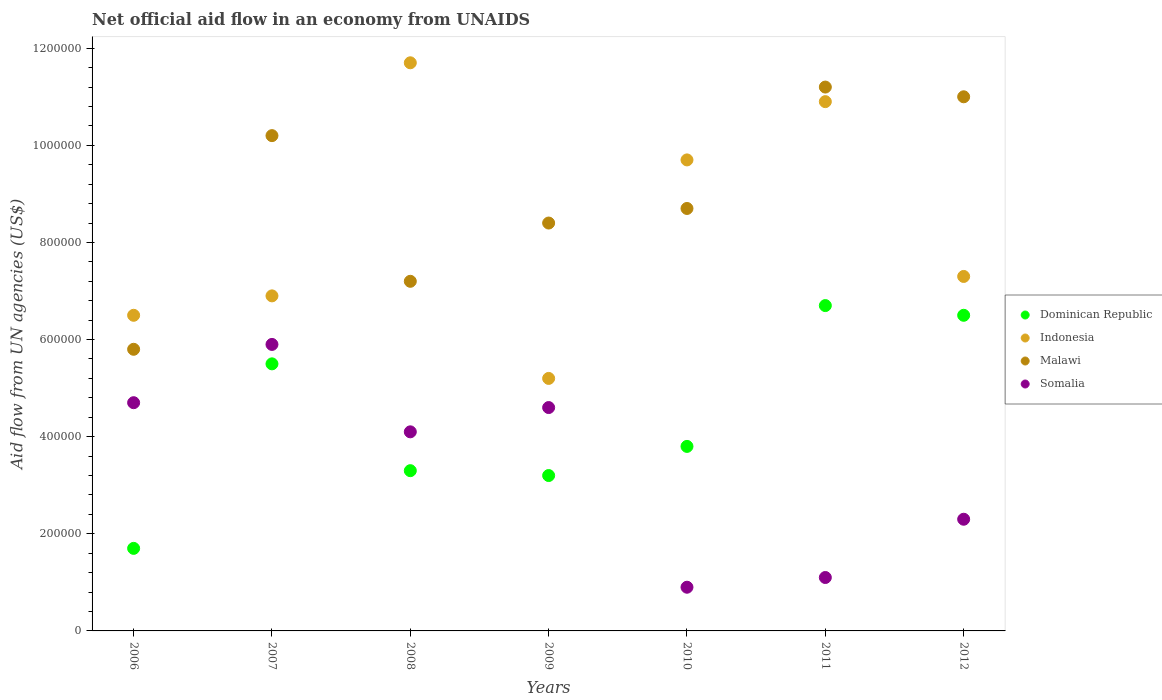How many different coloured dotlines are there?
Your response must be concise. 4. What is the net official aid flow in Indonesia in 2006?
Give a very brief answer. 6.50e+05. Across all years, what is the maximum net official aid flow in Malawi?
Offer a very short reply. 1.12e+06. Across all years, what is the minimum net official aid flow in Somalia?
Give a very brief answer. 9.00e+04. In which year was the net official aid flow in Somalia maximum?
Ensure brevity in your answer.  2007. In which year was the net official aid flow in Somalia minimum?
Offer a terse response. 2010. What is the total net official aid flow in Dominican Republic in the graph?
Provide a succinct answer. 3.07e+06. What is the difference between the net official aid flow in Somalia in 2009 and that in 2010?
Give a very brief answer. 3.70e+05. What is the difference between the net official aid flow in Malawi in 2007 and the net official aid flow in Dominican Republic in 2010?
Offer a terse response. 6.40e+05. What is the average net official aid flow in Dominican Republic per year?
Your response must be concise. 4.39e+05. In the year 2012, what is the difference between the net official aid flow in Somalia and net official aid flow in Dominican Republic?
Offer a terse response. -4.20e+05. What is the ratio of the net official aid flow in Dominican Republic in 2007 to that in 2011?
Your answer should be compact. 0.82. Is the difference between the net official aid flow in Somalia in 2007 and 2011 greater than the difference between the net official aid flow in Dominican Republic in 2007 and 2011?
Offer a very short reply. Yes. What is the difference between the highest and the second highest net official aid flow in Indonesia?
Offer a terse response. 8.00e+04. What is the difference between the highest and the lowest net official aid flow in Somalia?
Make the answer very short. 5.00e+05. Is the sum of the net official aid flow in Malawi in 2006 and 2009 greater than the maximum net official aid flow in Indonesia across all years?
Your response must be concise. Yes. Is it the case that in every year, the sum of the net official aid flow in Malawi and net official aid flow in Dominican Republic  is greater than the sum of net official aid flow in Indonesia and net official aid flow in Somalia?
Keep it short and to the point. No. Is the net official aid flow in Somalia strictly less than the net official aid flow in Dominican Republic over the years?
Make the answer very short. No. What is the difference between two consecutive major ticks on the Y-axis?
Provide a short and direct response. 2.00e+05. Does the graph contain any zero values?
Offer a very short reply. No. Does the graph contain grids?
Your answer should be very brief. No. Where does the legend appear in the graph?
Your answer should be compact. Center right. How are the legend labels stacked?
Offer a terse response. Vertical. What is the title of the graph?
Provide a short and direct response. Net official aid flow in an economy from UNAIDS. Does "Middle East & North Africa (developing only)" appear as one of the legend labels in the graph?
Offer a very short reply. No. What is the label or title of the Y-axis?
Your answer should be very brief. Aid flow from UN agencies (US$). What is the Aid flow from UN agencies (US$) in Indonesia in 2006?
Offer a terse response. 6.50e+05. What is the Aid flow from UN agencies (US$) in Malawi in 2006?
Your answer should be compact. 5.80e+05. What is the Aid flow from UN agencies (US$) in Somalia in 2006?
Provide a succinct answer. 4.70e+05. What is the Aid flow from UN agencies (US$) of Dominican Republic in 2007?
Offer a terse response. 5.50e+05. What is the Aid flow from UN agencies (US$) in Indonesia in 2007?
Your answer should be very brief. 6.90e+05. What is the Aid flow from UN agencies (US$) in Malawi in 2007?
Give a very brief answer. 1.02e+06. What is the Aid flow from UN agencies (US$) of Somalia in 2007?
Your response must be concise. 5.90e+05. What is the Aid flow from UN agencies (US$) in Indonesia in 2008?
Provide a succinct answer. 1.17e+06. What is the Aid flow from UN agencies (US$) in Malawi in 2008?
Provide a succinct answer. 7.20e+05. What is the Aid flow from UN agencies (US$) in Indonesia in 2009?
Offer a very short reply. 5.20e+05. What is the Aid flow from UN agencies (US$) in Malawi in 2009?
Your answer should be very brief. 8.40e+05. What is the Aid flow from UN agencies (US$) of Dominican Republic in 2010?
Ensure brevity in your answer.  3.80e+05. What is the Aid flow from UN agencies (US$) in Indonesia in 2010?
Your response must be concise. 9.70e+05. What is the Aid flow from UN agencies (US$) in Malawi in 2010?
Provide a short and direct response. 8.70e+05. What is the Aid flow from UN agencies (US$) of Dominican Republic in 2011?
Give a very brief answer. 6.70e+05. What is the Aid flow from UN agencies (US$) of Indonesia in 2011?
Offer a terse response. 1.09e+06. What is the Aid flow from UN agencies (US$) of Malawi in 2011?
Your answer should be compact. 1.12e+06. What is the Aid flow from UN agencies (US$) of Dominican Republic in 2012?
Provide a succinct answer. 6.50e+05. What is the Aid flow from UN agencies (US$) in Indonesia in 2012?
Offer a terse response. 7.30e+05. What is the Aid flow from UN agencies (US$) of Malawi in 2012?
Your answer should be compact. 1.10e+06. What is the Aid flow from UN agencies (US$) of Somalia in 2012?
Offer a very short reply. 2.30e+05. Across all years, what is the maximum Aid flow from UN agencies (US$) of Dominican Republic?
Give a very brief answer. 6.70e+05. Across all years, what is the maximum Aid flow from UN agencies (US$) of Indonesia?
Your answer should be very brief. 1.17e+06. Across all years, what is the maximum Aid flow from UN agencies (US$) in Malawi?
Offer a terse response. 1.12e+06. Across all years, what is the maximum Aid flow from UN agencies (US$) of Somalia?
Ensure brevity in your answer.  5.90e+05. Across all years, what is the minimum Aid flow from UN agencies (US$) of Dominican Republic?
Provide a short and direct response. 1.70e+05. Across all years, what is the minimum Aid flow from UN agencies (US$) in Indonesia?
Provide a succinct answer. 5.20e+05. Across all years, what is the minimum Aid flow from UN agencies (US$) in Malawi?
Offer a very short reply. 5.80e+05. Across all years, what is the minimum Aid flow from UN agencies (US$) in Somalia?
Your response must be concise. 9.00e+04. What is the total Aid flow from UN agencies (US$) of Dominican Republic in the graph?
Offer a terse response. 3.07e+06. What is the total Aid flow from UN agencies (US$) in Indonesia in the graph?
Make the answer very short. 5.82e+06. What is the total Aid flow from UN agencies (US$) of Malawi in the graph?
Offer a very short reply. 6.25e+06. What is the total Aid flow from UN agencies (US$) of Somalia in the graph?
Provide a succinct answer. 2.36e+06. What is the difference between the Aid flow from UN agencies (US$) of Dominican Republic in 2006 and that in 2007?
Provide a short and direct response. -3.80e+05. What is the difference between the Aid flow from UN agencies (US$) in Malawi in 2006 and that in 2007?
Your answer should be very brief. -4.40e+05. What is the difference between the Aid flow from UN agencies (US$) in Dominican Republic in 2006 and that in 2008?
Offer a terse response. -1.60e+05. What is the difference between the Aid flow from UN agencies (US$) in Indonesia in 2006 and that in 2008?
Offer a very short reply. -5.20e+05. What is the difference between the Aid flow from UN agencies (US$) in Malawi in 2006 and that in 2008?
Ensure brevity in your answer.  -1.40e+05. What is the difference between the Aid flow from UN agencies (US$) in Somalia in 2006 and that in 2008?
Make the answer very short. 6.00e+04. What is the difference between the Aid flow from UN agencies (US$) in Malawi in 2006 and that in 2009?
Your answer should be compact. -2.60e+05. What is the difference between the Aid flow from UN agencies (US$) in Somalia in 2006 and that in 2009?
Make the answer very short. 10000. What is the difference between the Aid flow from UN agencies (US$) in Dominican Republic in 2006 and that in 2010?
Ensure brevity in your answer.  -2.10e+05. What is the difference between the Aid flow from UN agencies (US$) of Indonesia in 2006 and that in 2010?
Make the answer very short. -3.20e+05. What is the difference between the Aid flow from UN agencies (US$) of Somalia in 2006 and that in 2010?
Keep it short and to the point. 3.80e+05. What is the difference between the Aid flow from UN agencies (US$) of Dominican Republic in 2006 and that in 2011?
Offer a terse response. -5.00e+05. What is the difference between the Aid flow from UN agencies (US$) of Indonesia in 2006 and that in 2011?
Give a very brief answer. -4.40e+05. What is the difference between the Aid flow from UN agencies (US$) of Malawi in 2006 and that in 2011?
Offer a terse response. -5.40e+05. What is the difference between the Aid flow from UN agencies (US$) in Somalia in 2006 and that in 2011?
Offer a terse response. 3.60e+05. What is the difference between the Aid flow from UN agencies (US$) of Dominican Republic in 2006 and that in 2012?
Your response must be concise. -4.80e+05. What is the difference between the Aid flow from UN agencies (US$) in Indonesia in 2006 and that in 2012?
Your answer should be compact. -8.00e+04. What is the difference between the Aid flow from UN agencies (US$) in Malawi in 2006 and that in 2012?
Keep it short and to the point. -5.20e+05. What is the difference between the Aid flow from UN agencies (US$) of Somalia in 2006 and that in 2012?
Give a very brief answer. 2.40e+05. What is the difference between the Aid flow from UN agencies (US$) of Dominican Republic in 2007 and that in 2008?
Offer a very short reply. 2.20e+05. What is the difference between the Aid flow from UN agencies (US$) of Indonesia in 2007 and that in 2008?
Ensure brevity in your answer.  -4.80e+05. What is the difference between the Aid flow from UN agencies (US$) in Malawi in 2007 and that in 2008?
Provide a short and direct response. 3.00e+05. What is the difference between the Aid flow from UN agencies (US$) in Dominican Republic in 2007 and that in 2009?
Offer a terse response. 2.30e+05. What is the difference between the Aid flow from UN agencies (US$) of Indonesia in 2007 and that in 2009?
Offer a terse response. 1.70e+05. What is the difference between the Aid flow from UN agencies (US$) of Somalia in 2007 and that in 2009?
Offer a very short reply. 1.30e+05. What is the difference between the Aid flow from UN agencies (US$) in Indonesia in 2007 and that in 2010?
Provide a short and direct response. -2.80e+05. What is the difference between the Aid flow from UN agencies (US$) of Somalia in 2007 and that in 2010?
Ensure brevity in your answer.  5.00e+05. What is the difference between the Aid flow from UN agencies (US$) of Indonesia in 2007 and that in 2011?
Provide a succinct answer. -4.00e+05. What is the difference between the Aid flow from UN agencies (US$) of Malawi in 2007 and that in 2011?
Make the answer very short. -1.00e+05. What is the difference between the Aid flow from UN agencies (US$) in Somalia in 2007 and that in 2011?
Offer a very short reply. 4.80e+05. What is the difference between the Aid flow from UN agencies (US$) in Indonesia in 2007 and that in 2012?
Your response must be concise. -4.00e+04. What is the difference between the Aid flow from UN agencies (US$) in Indonesia in 2008 and that in 2009?
Provide a short and direct response. 6.50e+05. What is the difference between the Aid flow from UN agencies (US$) in Malawi in 2008 and that in 2010?
Offer a terse response. -1.50e+05. What is the difference between the Aid flow from UN agencies (US$) in Somalia in 2008 and that in 2010?
Keep it short and to the point. 3.20e+05. What is the difference between the Aid flow from UN agencies (US$) in Dominican Republic in 2008 and that in 2011?
Make the answer very short. -3.40e+05. What is the difference between the Aid flow from UN agencies (US$) in Indonesia in 2008 and that in 2011?
Your answer should be compact. 8.00e+04. What is the difference between the Aid flow from UN agencies (US$) in Malawi in 2008 and that in 2011?
Keep it short and to the point. -4.00e+05. What is the difference between the Aid flow from UN agencies (US$) of Dominican Republic in 2008 and that in 2012?
Offer a very short reply. -3.20e+05. What is the difference between the Aid flow from UN agencies (US$) of Indonesia in 2008 and that in 2012?
Offer a very short reply. 4.40e+05. What is the difference between the Aid flow from UN agencies (US$) in Malawi in 2008 and that in 2012?
Your answer should be compact. -3.80e+05. What is the difference between the Aid flow from UN agencies (US$) of Somalia in 2008 and that in 2012?
Provide a short and direct response. 1.80e+05. What is the difference between the Aid flow from UN agencies (US$) in Indonesia in 2009 and that in 2010?
Keep it short and to the point. -4.50e+05. What is the difference between the Aid flow from UN agencies (US$) of Malawi in 2009 and that in 2010?
Your answer should be compact. -3.00e+04. What is the difference between the Aid flow from UN agencies (US$) of Dominican Republic in 2009 and that in 2011?
Your answer should be very brief. -3.50e+05. What is the difference between the Aid flow from UN agencies (US$) of Indonesia in 2009 and that in 2011?
Offer a very short reply. -5.70e+05. What is the difference between the Aid flow from UN agencies (US$) in Malawi in 2009 and that in 2011?
Offer a terse response. -2.80e+05. What is the difference between the Aid flow from UN agencies (US$) in Dominican Republic in 2009 and that in 2012?
Keep it short and to the point. -3.30e+05. What is the difference between the Aid flow from UN agencies (US$) in Malawi in 2009 and that in 2012?
Your answer should be compact. -2.60e+05. What is the difference between the Aid flow from UN agencies (US$) in Malawi in 2010 and that in 2012?
Your response must be concise. -2.30e+05. What is the difference between the Aid flow from UN agencies (US$) in Somalia in 2010 and that in 2012?
Your response must be concise. -1.40e+05. What is the difference between the Aid flow from UN agencies (US$) in Indonesia in 2011 and that in 2012?
Ensure brevity in your answer.  3.60e+05. What is the difference between the Aid flow from UN agencies (US$) of Dominican Republic in 2006 and the Aid flow from UN agencies (US$) of Indonesia in 2007?
Make the answer very short. -5.20e+05. What is the difference between the Aid flow from UN agencies (US$) in Dominican Republic in 2006 and the Aid flow from UN agencies (US$) in Malawi in 2007?
Your answer should be very brief. -8.50e+05. What is the difference between the Aid flow from UN agencies (US$) in Dominican Republic in 2006 and the Aid flow from UN agencies (US$) in Somalia in 2007?
Offer a very short reply. -4.20e+05. What is the difference between the Aid flow from UN agencies (US$) in Indonesia in 2006 and the Aid flow from UN agencies (US$) in Malawi in 2007?
Ensure brevity in your answer.  -3.70e+05. What is the difference between the Aid flow from UN agencies (US$) in Indonesia in 2006 and the Aid flow from UN agencies (US$) in Somalia in 2007?
Make the answer very short. 6.00e+04. What is the difference between the Aid flow from UN agencies (US$) in Dominican Republic in 2006 and the Aid flow from UN agencies (US$) in Indonesia in 2008?
Provide a short and direct response. -1.00e+06. What is the difference between the Aid flow from UN agencies (US$) in Dominican Republic in 2006 and the Aid flow from UN agencies (US$) in Malawi in 2008?
Make the answer very short. -5.50e+05. What is the difference between the Aid flow from UN agencies (US$) of Dominican Republic in 2006 and the Aid flow from UN agencies (US$) of Somalia in 2008?
Keep it short and to the point. -2.40e+05. What is the difference between the Aid flow from UN agencies (US$) of Indonesia in 2006 and the Aid flow from UN agencies (US$) of Malawi in 2008?
Ensure brevity in your answer.  -7.00e+04. What is the difference between the Aid flow from UN agencies (US$) of Indonesia in 2006 and the Aid flow from UN agencies (US$) of Somalia in 2008?
Offer a very short reply. 2.40e+05. What is the difference between the Aid flow from UN agencies (US$) in Dominican Republic in 2006 and the Aid flow from UN agencies (US$) in Indonesia in 2009?
Provide a short and direct response. -3.50e+05. What is the difference between the Aid flow from UN agencies (US$) in Dominican Republic in 2006 and the Aid flow from UN agencies (US$) in Malawi in 2009?
Provide a short and direct response. -6.70e+05. What is the difference between the Aid flow from UN agencies (US$) in Indonesia in 2006 and the Aid flow from UN agencies (US$) in Malawi in 2009?
Provide a short and direct response. -1.90e+05. What is the difference between the Aid flow from UN agencies (US$) of Dominican Republic in 2006 and the Aid flow from UN agencies (US$) of Indonesia in 2010?
Give a very brief answer. -8.00e+05. What is the difference between the Aid flow from UN agencies (US$) of Dominican Republic in 2006 and the Aid flow from UN agencies (US$) of Malawi in 2010?
Provide a succinct answer. -7.00e+05. What is the difference between the Aid flow from UN agencies (US$) in Indonesia in 2006 and the Aid flow from UN agencies (US$) in Somalia in 2010?
Your answer should be very brief. 5.60e+05. What is the difference between the Aid flow from UN agencies (US$) of Malawi in 2006 and the Aid flow from UN agencies (US$) of Somalia in 2010?
Provide a succinct answer. 4.90e+05. What is the difference between the Aid flow from UN agencies (US$) in Dominican Republic in 2006 and the Aid flow from UN agencies (US$) in Indonesia in 2011?
Your answer should be compact. -9.20e+05. What is the difference between the Aid flow from UN agencies (US$) of Dominican Republic in 2006 and the Aid flow from UN agencies (US$) of Malawi in 2011?
Your answer should be compact. -9.50e+05. What is the difference between the Aid flow from UN agencies (US$) of Dominican Republic in 2006 and the Aid flow from UN agencies (US$) of Somalia in 2011?
Your answer should be very brief. 6.00e+04. What is the difference between the Aid flow from UN agencies (US$) in Indonesia in 2006 and the Aid flow from UN agencies (US$) in Malawi in 2011?
Ensure brevity in your answer.  -4.70e+05. What is the difference between the Aid flow from UN agencies (US$) in Indonesia in 2006 and the Aid flow from UN agencies (US$) in Somalia in 2011?
Ensure brevity in your answer.  5.40e+05. What is the difference between the Aid flow from UN agencies (US$) in Malawi in 2006 and the Aid flow from UN agencies (US$) in Somalia in 2011?
Your response must be concise. 4.70e+05. What is the difference between the Aid flow from UN agencies (US$) of Dominican Republic in 2006 and the Aid flow from UN agencies (US$) of Indonesia in 2012?
Provide a succinct answer. -5.60e+05. What is the difference between the Aid flow from UN agencies (US$) in Dominican Republic in 2006 and the Aid flow from UN agencies (US$) in Malawi in 2012?
Provide a succinct answer. -9.30e+05. What is the difference between the Aid flow from UN agencies (US$) of Dominican Republic in 2006 and the Aid flow from UN agencies (US$) of Somalia in 2012?
Make the answer very short. -6.00e+04. What is the difference between the Aid flow from UN agencies (US$) of Indonesia in 2006 and the Aid flow from UN agencies (US$) of Malawi in 2012?
Provide a succinct answer. -4.50e+05. What is the difference between the Aid flow from UN agencies (US$) of Indonesia in 2006 and the Aid flow from UN agencies (US$) of Somalia in 2012?
Provide a short and direct response. 4.20e+05. What is the difference between the Aid flow from UN agencies (US$) in Dominican Republic in 2007 and the Aid flow from UN agencies (US$) in Indonesia in 2008?
Your response must be concise. -6.20e+05. What is the difference between the Aid flow from UN agencies (US$) in Dominican Republic in 2007 and the Aid flow from UN agencies (US$) in Malawi in 2008?
Give a very brief answer. -1.70e+05. What is the difference between the Aid flow from UN agencies (US$) in Indonesia in 2007 and the Aid flow from UN agencies (US$) in Somalia in 2008?
Offer a terse response. 2.80e+05. What is the difference between the Aid flow from UN agencies (US$) of Dominican Republic in 2007 and the Aid flow from UN agencies (US$) of Indonesia in 2009?
Offer a very short reply. 3.00e+04. What is the difference between the Aid flow from UN agencies (US$) of Indonesia in 2007 and the Aid flow from UN agencies (US$) of Malawi in 2009?
Provide a succinct answer. -1.50e+05. What is the difference between the Aid flow from UN agencies (US$) in Indonesia in 2007 and the Aid flow from UN agencies (US$) in Somalia in 2009?
Offer a terse response. 2.30e+05. What is the difference between the Aid flow from UN agencies (US$) of Malawi in 2007 and the Aid flow from UN agencies (US$) of Somalia in 2009?
Your answer should be compact. 5.60e+05. What is the difference between the Aid flow from UN agencies (US$) of Dominican Republic in 2007 and the Aid flow from UN agencies (US$) of Indonesia in 2010?
Keep it short and to the point. -4.20e+05. What is the difference between the Aid flow from UN agencies (US$) in Dominican Republic in 2007 and the Aid flow from UN agencies (US$) in Malawi in 2010?
Keep it short and to the point. -3.20e+05. What is the difference between the Aid flow from UN agencies (US$) in Dominican Republic in 2007 and the Aid flow from UN agencies (US$) in Somalia in 2010?
Your answer should be very brief. 4.60e+05. What is the difference between the Aid flow from UN agencies (US$) of Indonesia in 2007 and the Aid flow from UN agencies (US$) of Malawi in 2010?
Your response must be concise. -1.80e+05. What is the difference between the Aid flow from UN agencies (US$) of Malawi in 2007 and the Aid flow from UN agencies (US$) of Somalia in 2010?
Make the answer very short. 9.30e+05. What is the difference between the Aid flow from UN agencies (US$) in Dominican Republic in 2007 and the Aid flow from UN agencies (US$) in Indonesia in 2011?
Offer a very short reply. -5.40e+05. What is the difference between the Aid flow from UN agencies (US$) in Dominican Republic in 2007 and the Aid flow from UN agencies (US$) in Malawi in 2011?
Give a very brief answer. -5.70e+05. What is the difference between the Aid flow from UN agencies (US$) of Dominican Republic in 2007 and the Aid flow from UN agencies (US$) of Somalia in 2011?
Your answer should be compact. 4.40e+05. What is the difference between the Aid flow from UN agencies (US$) of Indonesia in 2007 and the Aid flow from UN agencies (US$) of Malawi in 2011?
Make the answer very short. -4.30e+05. What is the difference between the Aid flow from UN agencies (US$) in Indonesia in 2007 and the Aid flow from UN agencies (US$) in Somalia in 2011?
Provide a short and direct response. 5.80e+05. What is the difference between the Aid flow from UN agencies (US$) of Malawi in 2007 and the Aid flow from UN agencies (US$) of Somalia in 2011?
Provide a succinct answer. 9.10e+05. What is the difference between the Aid flow from UN agencies (US$) in Dominican Republic in 2007 and the Aid flow from UN agencies (US$) in Malawi in 2012?
Keep it short and to the point. -5.50e+05. What is the difference between the Aid flow from UN agencies (US$) in Dominican Republic in 2007 and the Aid flow from UN agencies (US$) in Somalia in 2012?
Keep it short and to the point. 3.20e+05. What is the difference between the Aid flow from UN agencies (US$) in Indonesia in 2007 and the Aid flow from UN agencies (US$) in Malawi in 2012?
Offer a very short reply. -4.10e+05. What is the difference between the Aid flow from UN agencies (US$) of Indonesia in 2007 and the Aid flow from UN agencies (US$) of Somalia in 2012?
Your response must be concise. 4.60e+05. What is the difference between the Aid flow from UN agencies (US$) of Malawi in 2007 and the Aid flow from UN agencies (US$) of Somalia in 2012?
Offer a terse response. 7.90e+05. What is the difference between the Aid flow from UN agencies (US$) of Dominican Republic in 2008 and the Aid flow from UN agencies (US$) of Malawi in 2009?
Provide a succinct answer. -5.10e+05. What is the difference between the Aid flow from UN agencies (US$) in Dominican Republic in 2008 and the Aid flow from UN agencies (US$) in Somalia in 2009?
Offer a terse response. -1.30e+05. What is the difference between the Aid flow from UN agencies (US$) in Indonesia in 2008 and the Aid flow from UN agencies (US$) in Somalia in 2009?
Your answer should be compact. 7.10e+05. What is the difference between the Aid flow from UN agencies (US$) in Malawi in 2008 and the Aid flow from UN agencies (US$) in Somalia in 2009?
Make the answer very short. 2.60e+05. What is the difference between the Aid flow from UN agencies (US$) of Dominican Republic in 2008 and the Aid flow from UN agencies (US$) of Indonesia in 2010?
Make the answer very short. -6.40e+05. What is the difference between the Aid flow from UN agencies (US$) in Dominican Republic in 2008 and the Aid flow from UN agencies (US$) in Malawi in 2010?
Make the answer very short. -5.40e+05. What is the difference between the Aid flow from UN agencies (US$) of Indonesia in 2008 and the Aid flow from UN agencies (US$) of Somalia in 2010?
Ensure brevity in your answer.  1.08e+06. What is the difference between the Aid flow from UN agencies (US$) of Malawi in 2008 and the Aid flow from UN agencies (US$) of Somalia in 2010?
Your answer should be compact. 6.30e+05. What is the difference between the Aid flow from UN agencies (US$) of Dominican Republic in 2008 and the Aid flow from UN agencies (US$) of Indonesia in 2011?
Make the answer very short. -7.60e+05. What is the difference between the Aid flow from UN agencies (US$) of Dominican Republic in 2008 and the Aid flow from UN agencies (US$) of Malawi in 2011?
Ensure brevity in your answer.  -7.90e+05. What is the difference between the Aid flow from UN agencies (US$) in Dominican Republic in 2008 and the Aid flow from UN agencies (US$) in Somalia in 2011?
Provide a short and direct response. 2.20e+05. What is the difference between the Aid flow from UN agencies (US$) of Indonesia in 2008 and the Aid flow from UN agencies (US$) of Malawi in 2011?
Keep it short and to the point. 5.00e+04. What is the difference between the Aid flow from UN agencies (US$) in Indonesia in 2008 and the Aid flow from UN agencies (US$) in Somalia in 2011?
Your response must be concise. 1.06e+06. What is the difference between the Aid flow from UN agencies (US$) of Malawi in 2008 and the Aid flow from UN agencies (US$) of Somalia in 2011?
Your response must be concise. 6.10e+05. What is the difference between the Aid flow from UN agencies (US$) in Dominican Republic in 2008 and the Aid flow from UN agencies (US$) in Indonesia in 2012?
Offer a terse response. -4.00e+05. What is the difference between the Aid flow from UN agencies (US$) of Dominican Republic in 2008 and the Aid flow from UN agencies (US$) of Malawi in 2012?
Your answer should be compact. -7.70e+05. What is the difference between the Aid flow from UN agencies (US$) of Indonesia in 2008 and the Aid flow from UN agencies (US$) of Malawi in 2012?
Give a very brief answer. 7.00e+04. What is the difference between the Aid flow from UN agencies (US$) in Indonesia in 2008 and the Aid flow from UN agencies (US$) in Somalia in 2012?
Your answer should be very brief. 9.40e+05. What is the difference between the Aid flow from UN agencies (US$) in Dominican Republic in 2009 and the Aid flow from UN agencies (US$) in Indonesia in 2010?
Keep it short and to the point. -6.50e+05. What is the difference between the Aid flow from UN agencies (US$) in Dominican Republic in 2009 and the Aid flow from UN agencies (US$) in Malawi in 2010?
Provide a short and direct response. -5.50e+05. What is the difference between the Aid flow from UN agencies (US$) in Indonesia in 2009 and the Aid flow from UN agencies (US$) in Malawi in 2010?
Offer a very short reply. -3.50e+05. What is the difference between the Aid flow from UN agencies (US$) in Malawi in 2009 and the Aid flow from UN agencies (US$) in Somalia in 2010?
Your answer should be compact. 7.50e+05. What is the difference between the Aid flow from UN agencies (US$) in Dominican Republic in 2009 and the Aid flow from UN agencies (US$) in Indonesia in 2011?
Ensure brevity in your answer.  -7.70e+05. What is the difference between the Aid flow from UN agencies (US$) of Dominican Republic in 2009 and the Aid flow from UN agencies (US$) of Malawi in 2011?
Offer a terse response. -8.00e+05. What is the difference between the Aid flow from UN agencies (US$) of Indonesia in 2009 and the Aid flow from UN agencies (US$) of Malawi in 2011?
Provide a short and direct response. -6.00e+05. What is the difference between the Aid flow from UN agencies (US$) in Malawi in 2009 and the Aid flow from UN agencies (US$) in Somalia in 2011?
Provide a short and direct response. 7.30e+05. What is the difference between the Aid flow from UN agencies (US$) of Dominican Republic in 2009 and the Aid flow from UN agencies (US$) of Indonesia in 2012?
Provide a succinct answer. -4.10e+05. What is the difference between the Aid flow from UN agencies (US$) in Dominican Republic in 2009 and the Aid flow from UN agencies (US$) in Malawi in 2012?
Your answer should be compact. -7.80e+05. What is the difference between the Aid flow from UN agencies (US$) in Dominican Republic in 2009 and the Aid flow from UN agencies (US$) in Somalia in 2012?
Your answer should be very brief. 9.00e+04. What is the difference between the Aid flow from UN agencies (US$) of Indonesia in 2009 and the Aid flow from UN agencies (US$) of Malawi in 2012?
Ensure brevity in your answer.  -5.80e+05. What is the difference between the Aid flow from UN agencies (US$) in Indonesia in 2009 and the Aid flow from UN agencies (US$) in Somalia in 2012?
Make the answer very short. 2.90e+05. What is the difference between the Aid flow from UN agencies (US$) in Malawi in 2009 and the Aid flow from UN agencies (US$) in Somalia in 2012?
Keep it short and to the point. 6.10e+05. What is the difference between the Aid flow from UN agencies (US$) in Dominican Republic in 2010 and the Aid flow from UN agencies (US$) in Indonesia in 2011?
Your answer should be very brief. -7.10e+05. What is the difference between the Aid flow from UN agencies (US$) of Dominican Republic in 2010 and the Aid flow from UN agencies (US$) of Malawi in 2011?
Make the answer very short. -7.40e+05. What is the difference between the Aid flow from UN agencies (US$) in Dominican Republic in 2010 and the Aid flow from UN agencies (US$) in Somalia in 2011?
Give a very brief answer. 2.70e+05. What is the difference between the Aid flow from UN agencies (US$) in Indonesia in 2010 and the Aid flow from UN agencies (US$) in Malawi in 2011?
Your response must be concise. -1.50e+05. What is the difference between the Aid flow from UN agencies (US$) in Indonesia in 2010 and the Aid flow from UN agencies (US$) in Somalia in 2011?
Give a very brief answer. 8.60e+05. What is the difference between the Aid flow from UN agencies (US$) in Malawi in 2010 and the Aid flow from UN agencies (US$) in Somalia in 2011?
Your response must be concise. 7.60e+05. What is the difference between the Aid flow from UN agencies (US$) in Dominican Republic in 2010 and the Aid flow from UN agencies (US$) in Indonesia in 2012?
Your answer should be very brief. -3.50e+05. What is the difference between the Aid flow from UN agencies (US$) of Dominican Republic in 2010 and the Aid flow from UN agencies (US$) of Malawi in 2012?
Your response must be concise. -7.20e+05. What is the difference between the Aid flow from UN agencies (US$) of Dominican Republic in 2010 and the Aid flow from UN agencies (US$) of Somalia in 2012?
Offer a terse response. 1.50e+05. What is the difference between the Aid flow from UN agencies (US$) of Indonesia in 2010 and the Aid flow from UN agencies (US$) of Malawi in 2012?
Make the answer very short. -1.30e+05. What is the difference between the Aid flow from UN agencies (US$) in Indonesia in 2010 and the Aid flow from UN agencies (US$) in Somalia in 2012?
Keep it short and to the point. 7.40e+05. What is the difference between the Aid flow from UN agencies (US$) in Malawi in 2010 and the Aid flow from UN agencies (US$) in Somalia in 2012?
Ensure brevity in your answer.  6.40e+05. What is the difference between the Aid flow from UN agencies (US$) of Dominican Republic in 2011 and the Aid flow from UN agencies (US$) of Malawi in 2012?
Make the answer very short. -4.30e+05. What is the difference between the Aid flow from UN agencies (US$) of Dominican Republic in 2011 and the Aid flow from UN agencies (US$) of Somalia in 2012?
Give a very brief answer. 4.40e+05. What is the difference between the Aid flow from UN agencies (US$) of Indonesia in 2011 and the Aid flow from UN agencies (US$) of Malawi in 2012?
Your response must be concise. -10000. What is the difference between the Aid flow from UN agencies (US$) of Indonesia in 2011 and the Aid flow from UN agencies (US$) of Somalia in 2012?
Keep it short and to the point. 8.60e+05. What is the difference between the Aid flow from UN agencies (US$) of Malawi in 2011 and the Aid flow from UN agencies (US$) of Somalia in 2012?
Keep it short and to the point. 8.90e+05. What is the average Aid flow from UN agencies (US$) of Dominican Republic per year?
Keep it short and to the point. 4.39e+05. What is the average Aid flow from UN agencies (US$) of Indonesia per year?
Provide a succinct answer. 8.31e+05. What is the average Aid flow from UN agencies (US$) of Malawi per year?
Provide a succinct answer. 8.93e+05. What is the average Aid flow from UN agencies (US$) in Somalia per year?
Offer a very short reply. 3.37e+05. In the year 2006, what is the difference between the Aid flow from UN agencies (US$) of Dominican Republic and Aid flow from UN agencies (US$) of Indonesia?
Your response must be concise. -4.80e+05. In the year 2006, what is the difference between the Aid flow from UN agencies (US$) of Dominican Republic and Aid flow from UN agencies (US$) of Malawi?
Your response must be concise. -4.10e+05. In the year 2006, what is the difference between the Aid flow from UN agencies (US$) of Malawi and Aid flow from UN agencies (US$) of Somalia?
Your response must be concise. 1.10e+05. In the year 2007, what is the difference between the Aid flow from UN agencies (US$) of Dominican Republic and Aid flow from UN agencies (US$) of Malawi?
Offer a very short reply. -4.70e+05. In the year 2007, what is the difference between the Aid flow from UN agencies (US$) of Indonesia and Aid flow from UN agencies (US$) of Malawi?
Keep it short and to the point. -3.30e+05. In the year 2007, what is the difference between the Aid flow from UN agencies (US$) of Indonesia and Aid flow from UN agencies (US$) of Somalia?
Provide a short and direct response. 1.00e+05. In the year 2008, what is the difference between the Aid flow from UN agencies (US$) of Dominican Republic and Aid flow from UN agencies (US$) of Indonesia?
Your response must be concise. -8.40e+05. In the year 2008, what is the difference between the Aid flow from UN agencies (US$) in Dominican Republic and Aid flow from UN agencies (US$) in Malawi?
Provide a short and direct response. -3.90e+05. In the year 2008, what is the difference between the Aid flow from UN agencies (US$) in Dominican Republic and Aid flow from UN agencies (US$) in Somalia?
Provide a succinct answer. -8.00e+04. In the year 2008, what is the difference between the Aid flow from UN agencies (US$) in Indonesia and Aid flow from UN agencies (US$) in Somalia?
Ensure brevity in your answer.  7.60e+05. In the year 2009, what is the difference between the Aid flow from UN agencies (US$) in Dominican Republic and Aid flow from UN agencies (US$) in Indonesia?
Ensure brevity in your answer.  -2.00e+05. In the year 2009, what is the difference between the Aid flow from UN agencies (US$) of Dominican Republic and Aid flow from UN agencies (US$) of Malawi?
Keep it short and to the point. -5.20e+05. In the year 2009, what is the difference between the Aid flow from UN agencies (US$) of Dominican Republic and Aid flow from UN agencies (US$) of Somalia?
Your answer should be very brief. -1.40e+05. In the year 2009, what is the difference between the Aid flow from UN agencies (US$) in Indonesia and Aid flow from UN agencies (US$) in Malawi?
Give a very brief answer. -3.20e+05. In the year 2009, what is the difference between the Aid flow from UN agencies (US$) of Indonesia and Aid flow from UN agencies (US$) of Somalia?
Offer a terse response. 6.00e+04. In the year 2010, what is the difference between the Aid flow from UN agencies (US$) of Dominican Republic and Aid flow from UN agencies (US$) of Indonesia?
Provide a short and direct response. -5.90e+05. In the year 2010, what is the difference between the Aid flow from UN agencies (US$) of Dominican Republic and Aid flow from UN agencies (US$) of Malawi?
Ensure brevity in your answer.  -4.90e+05. In the year 2010, what is the difference between the Aid flow from UN agencies (US$) in Indonesia and Aid flow from UN agencies (US$) in Malawi?
Make the answer very short. 1.00e+05. In the year 2010, what is the difference between the Aid flow from UN agencies (US$) in Indonesia and Aid flow from UN agencies (US$) in Somalia?
Your answer should be compact. 8.80e+05. In the year 2010, what is the difference between the Aid flow from UN agencies (US$) in Malawi and Aid flow from UN agencies (US$) in Somalia?
Keep it short and to the point. 7.80e+05. In the year 2011, what is the difference between the Aid flow from UN agencies (US$) in Dominican Republic and Aid flow from UN agencies (US$) in Indonesia?
Make the answer very short. -4.20e+05. In the year 2011, what is the difference between the Aid flow from UN agencies (US$) of Dominican Republic and Aid flow from UN agencies (US$) of Malawi?
Your answer should be very brief. -4.50e+05. In the year 2011, what is the difference between the Aid flow from UN agencies (US$) of Dominican Republic and Aid flow from UN agencies (US$) of Somalia?
Keep it short and to the point. 5.60e+05. In the year 2011, what is the difference between the Aid flow from UN agencies (US$) of Indonesia and Aid flow from UN agencies (US$) of Somalia?
Offer a very short reply. 9.80e+05. In the year 2011, what is the difference between the Aid flow from UN agencies (US$) in Malawi and Aid flow from UN agencies (US$) in Somalia?
Your answer should be very brief. 1.01e+06. In the year 2012, what is the difference between the Aid flow from UN agencies (US$) of Dominican Republic and Aid flow from UN agencies (US$) of Indonesia?
Your answer should be very brief. -8.00e+04. In the year 2012, what is the difference between the Aid flow from UN agencies (US$) in Dominican Republic and Aid flow from UN agencies (US$) in Malawi?
Your answer should be compact. -4.50e+05. In the year 2012, what is the difference between the Aid flow from UN agencies (US$) of Dominican Republic and Aid flow from UN agencies (US$) of Somalia?
Offer a terse response. 4.20e+05. In the year 2012, what is the difference between the Aid flow from UN agencies (US$) in Indonesia and Aid flow from UN agencies (US$) in Malawi?
Your answer should be very brief. -3.70e+05. In the year 2012, what is the difference between the Aid flow from UN agencies (US$) in Indonesia and Aid flow from UN agencies (US$) in Somalia?
Ensure brevity in your answer.  5.00e+05. In the year 2012, what is the difference between the Aid flow from UN agencies (US$) of Malawi and Aid flow from UN agencies (US$) of Somalia?
Give a very brief answer. 8.70e+05. What is the ratio of the Aid flow from UN agencies (US$) in Dominican Republic in 2006 to that in 2007?
Provide a short and direct response. 0.31. What is the ratio of the Aid flow from UN agencies (US$) of Indonesia in 2006 to that in 2007?
Keep it short and to the point. 0.94. What is the ratio of the Aid flow from UN agencies (US$) of Malawi in 2006 to that in 2007?
Your answer should be very brief. 0.57. What is the ratio of the Aid flow from UN agencies (US$) of Somalia in 2006 to that in 2007?
Your answer should be very brief. 0.8. What is the ratio of the Aid flow from UN agencies (US$) in Dominican Republic in 2006 to that in 2008?
Your answer should be compact. 0.52. What is the ratio of the Aid flow from UN agencies (US$) of Indonesia in 2006 to that in 2008?
Make the answer very short. 0.56. What is the ratio of the Aid flow from UN agencies (US$) of Malawi in 2006 to that in 2008?
Make the answer very short. 0.81. What is the ratio of the Aid flow from UN agencies (US$) in Somalia in 2006 to that in 2008?
Your answer should be very brief. 1.15. What is the ratio of the Aid flow from UN agencies (US$) of Dominican Republic in 2006 to that in 2009?
Keep it short and to the point. 0.53. What is the ratio of the Aid flow from UN agencies (US$) of Indonesia in 2006 to that in 2009?
Give a very brief answer. 1.25. What is the ratio of the Aid flow from UN agencies (US$) in Malawi in 2006 to that in 2009?
Provide a short and direct response. 0.69. What is the ratio of the Aid flow from UN agencies (US$) of Somalia in 2006 to that in 2009?
Offer a terse response. 1.02. What is the ratio of the Aid flow from UN agencies (US$) in Dominican Republic in 2006 to that in 2010?
Provide a succinct answer. 0.45. What is the ratio of the Aid flow from UN agencies (US$) in Indonesia in 2006 to that in 2010?
Offer a very short reply. 0.67. What is the ratio of the Aid flow from UN agencies (US$) of Somalia in 2006 to that in 2010?
Provide a succinct answer. 5.22. What is the ratio of the Aid flow from UN agencies (US$) in Dominican Republic in 2006 to that in 2011?
Ensure brevity in your answer.  0.25. What is the ratio of the Aid flow from UN agencies (US$) in Indonesia in 2006 to that in 2011?
Give a very brief answer. 0.6. What is the ratio of the Aid flow from UN agencies (US$) of Malawi in 2006 to that in 2011?
Your answer should be very brief. 0.52. What is the ratio of the Aid flow from UN agencies (US$) in Somalia in 2006 to that in 2011?
Ensure brevity in your answer.  4.27. What is the ratio of the Aid flow from UN agencies (US$) of Dominican Republic in 2006 to that in 2012?
Offer a terse response. 0.26. What is the ratio of the Aid flow from UN agencies (US$) in Indonesia in 2006 to that in 2012?
Offer a very short reply. 0.89. What is the ratio of the Aid flow from UN agencies (US$) in Malawi in 2006 to that in 2012?
Keep it short and to the point. 0.53. What is the ratio of the Aid flow from UN agencies (US$) of Somalia in 2006 to that in 2012?
Offer a very short reply. 2.04. What is the ratio of the Aid flow from UN agencies (US$) of Dominican Republic in 2007 to that in 2008?
Make the answer very short. 1.67. What is the ratio of the Aid flow from UN agencies (US$) of Indonesia in 2007 to that in 2008?
Keep it short and to the point. 0.59. What is the ratio of the Aid flow from UN agencies (US$) in Malawi in 2007 to that in 2008?
Offer a terse response. 1.42. What is the ratio of the Aid flow from UN agencies (US$) of Somalia in 2007 to that in 2008?
Make the answer very short. 1.44. What is the ratio of the Aid flow from UN agencies (US$) of Dominican Republic in 2007 to that in 2009?
Give a very brief answer. 1.72. What is the ratio of the Aid flow from UN agencies (US$) of Indonesia in 2007 to that in 2009?
Give a very brief answer. 1.33. What is the ratio of the Aid flow from UN agencies (US$) of Malawi in 2007 to that in 2009?
Give a very brief answer. 1.21. What is the ratio of the Aid flow from UN agencies (US$) of Somalia in 2007 to that in 2009?
Your answer should be very brief. 1.28. What is the ratio of the Aid flow from UN agencies (US$) in Dominican Republic in 2007 to that in 2010?
Provide a succinct answer. 1.45. What is the ratio of the Aid flow from UN agencies (US$) in Indonesia in 2007 to that in 2010?
Make the answer very short. 0.71. What is the ratio of the Aid flow from UN agencies (US$) of Malawi in 2007 to that in 2010?
Your response must be concise. 1.17. What is the ratio of the Aid flow from UN agencies (US$) of Somalia in 2007 to that in 2010?
Make the answer very short. 6.56. What is the ratio of the Aid flow from UN agencies (US$) in Dominican Republic in 2007 to that in 2011?
Make the answer very short. 0.82. What is the ratio of the Aid flow from UN agencies (US$) in Indonesia in 2007 to that in 2011?
Ensure brevity in your answer.  0.63. What is the ratio of the Aid flow from UN agencies (US$) of Malawi in 2007 to that in 2011?
Keep it short and to the point. 0.91. What is the ratio of the Aid flow from UN agencies (US$) of Somalia in 2007 to that in 2011?
Make the answer very short. 5.36. What is the ratio of the Aid flow from UN agencies (US$) of Dominican Republic in 2007 to that in 2012?
Keep it short and to the point. 0.85. What is the ratio of the Aid flow from UN agencies (US$) of Indonesia in 2007 to that in 2012?
Keep it short and to the point. 0.95. What is the ratio of the Aid flow from UN agencies (US$) in Malawi in 2007 to that in 2012?
Make the answer very short. 0.93. What is the ratio of the Aid flow from UN agencies (US$) in Somalia in 2007 to that in 2012?
Offer a terse response. 2.57. What is the ratio of the Aid flow from UN agencies (US$) of Dominican Republic in 2008 to that in 2009?
Offer a terse response. 1.03. What is the ratio of the Aid flow from UN agencies (US$) in Indonesia in 2008 to that in 2009?
Offer a terse response. 2.25. What is the ratio of the Aid flow from UN agencies (US$) of Somalia in 2008 to that in 2009?
Provide a succinct answer. 0.89. What is the ratio of the Aid flow from UN agencies (US$) in Dominican Republic in 2008 to that in 2010?
Make the answer very short. 0.87. What is the ratio of the Aid flow from UN agencies (US$) in Indonesia in 2008 to that in 2010?
Provide a short and direct response. 1.21. What is the ratio of the Aid flow from UN agencies (US$) of Malawi in 2008 to that in 2010?
Give a very brief answer. 0.83. What is the ratio of the Aid flow from UN agencies (US$) of Somalia in 2008 to that in 2010?
Offer a very short reply. 4.56. What is the ratio of the Aid flow from UN agencies (US$) in Dominican Republic in 2008 to that in 2011?
Provide a succinct answer. 0.49. What is the ratio of the Aid flow from UN agencies (US$) of Indonesia in 2008 to that in 2011?
Your answer should be very brief. 1.07. What is the ratio of the Aid flow from UN agencies (US$) in Malawi in 2008 to that in 2011?
Your answer should be compact. 0.64. What is the ratio of the Aid flow from UN agencies (US$) of Somalia in 2008 to that in 2011?
Your answer should be compact. 3.73. What is the ratio of the Aid flow from UN agencies (US$) in Dominican Republic in 2008 to that in 2012?
Offer a very short reply. 0.51. What is the ratio of the Aid flow from UN agencies (US$) of Indonesia in 2008 to that in 2012?
Your answer should be very brief. 1.6. What is the ratio of the Aid flow from UN agencies (US$) of Malawi in 2008 to that in 2012?
Your answer should be very brief. 0.65. What is the ratio of the Aid flow from UN agencies (US$) in Somalia in 2008 to that in 2012?
Your answer should be compact. 1.78. What is the ratio of the Aid flow from UN agencies (US$) of Dominican Republic in 2009 to that in 2010?
Ensure brevity in your answer.  0.84. What is the ratio of the Aid flow from UN agencies (US$) in Indonesia in 2009 to that in 2010?
Provide a short and direct response. 0.54. What is the ratio of the Aid flow from UN agencies (US$) in Malawi in 2009 to that in 2010?
Keep it short and to the point. 0.97. What is the ratio of the Aid flow from UN agencies (US$) of Somalia in 2009 to that in 2010?
Keep it short and to the point. 5.11. What is the ratio of the Aid flow from UN agencies (US$) in Dominican Republic in 2009 to that in 2011?
Offer a very short reply. 0.48. What is the ratio of the Aid flow from UN agencies (US$) in Indonesia in 2009 to that in 2011?
Offer a terse response. 0.48. What is the ratio of the Aid flow from UN agencies (US$) in Malawi in 2009 to that in 2011?
Your response must be concise. 0.75. What is the ratio of the Aid flow from UN agencies (US$) in Somalia in 2009 to that in 2011?
Make the answer very short. 4.18. What is the ratio of the Aid flow from UN agencies (US$) of Dominican Republic in 2009 to that in 2012?
Give a very brief answer. 0.49. What is the ratio of the Aid flow from UN agencies (US$) of Indonesia in 2009 to that in 2012?
Keep it short and to the point. 0.71. What is the ratio of the Aid flow from UN agencies (US$) of Malawi in 2009 to that in 2012?
Your answer should be very brief. 0.76. What is the ratio of the Aid flow from UN agencies (US$) in Somalia in 2009 to that in 2012?
Give a very brief answer. 2. What is the ratio of the Aid flow from UN agencies (US$) in Dominican Republic in 2010 to that in 2011?
Offer a terse response. 0.57. What is the ratio of the Aid flow from UN agencies (US$) of Indonesia in 2010 to that in 2011?
Your answer should be compact. 0.89. What is the ratio of the Aid flow from UN agencies (US$) in Malawi in 2010 to that in 2011?
Make the answer very short. 0.78. What is the ratio of the Aid flow from UN agencies (US$) in Somalia in 2010 to that in 2011?
Your answer should be compact. 0.82. What is the ratio of the Aid flow from UN agencies (US$) in Dominican Republic in 2010 to that in 2012?
Give a very brief answer. 0.58. What is the ratio of the Aid flow from UN agencies (US$) of Indonesia in 2010 to that in 2012?
Your answer should be compact. 1.33. What is the ratio of the Aid flow from UN agencies (US$) in Malawi in 2010 to that in 2012?
Provide a succinct answer. 0.79. What is the ratio of the Aid flow from UN agencies (US$) in Somalia in 2010 to that in 2012?
Your response must be concise. 0.39. What is the ratio of the Aid flow from UN agencies (US$) of Dominican Republic in 2011 to that in 2012?
Make the answer very short. 1.03. What is the ratio of the Aid flow from UN agencies (US$) in Indonesia in 2011 to that in 2012?
Your answer should be compact. 1.49. What is the ratio of the Aid flow from UN agencies (US$) in Malawi in 2011 to that in 2012?
Give a very brief answer. 1.02. What is the ratio of the Aid flow from UN agencies (US$) in Somalia in 2011 to that in 2012?
Make the answer very short. 0.48. What is the difference between the highest and the second highest Aid flow from UN agencies (US$) of Indonesia?
Offer a terse response. 8.00e+04. What is the difference between the highest and the second highest Aid flow from UN agencies (US$) of Malawi?
Give a very brief answer. 2.00e+04. What is the difference between the highest and the second highest Aid flow from UN agencies (US$) of Somalia?
Keep it short and to the point. 1.20e+05. What is the difference between the highest and the lowest Aid flow from UN agencies (US$) of Indonesia?
Provide a short and direct response. 6.50e+05. What is the difference between the highest and the lowest Aid flow from UN agencies (US$) in Malawi?
Your answer should be very brief. 5.40e+05. What is the difference between the highest and the lowest Aid flow from UN agencies (US$) in Somalia?
Your answer should be very brief. 5.00e+05. 